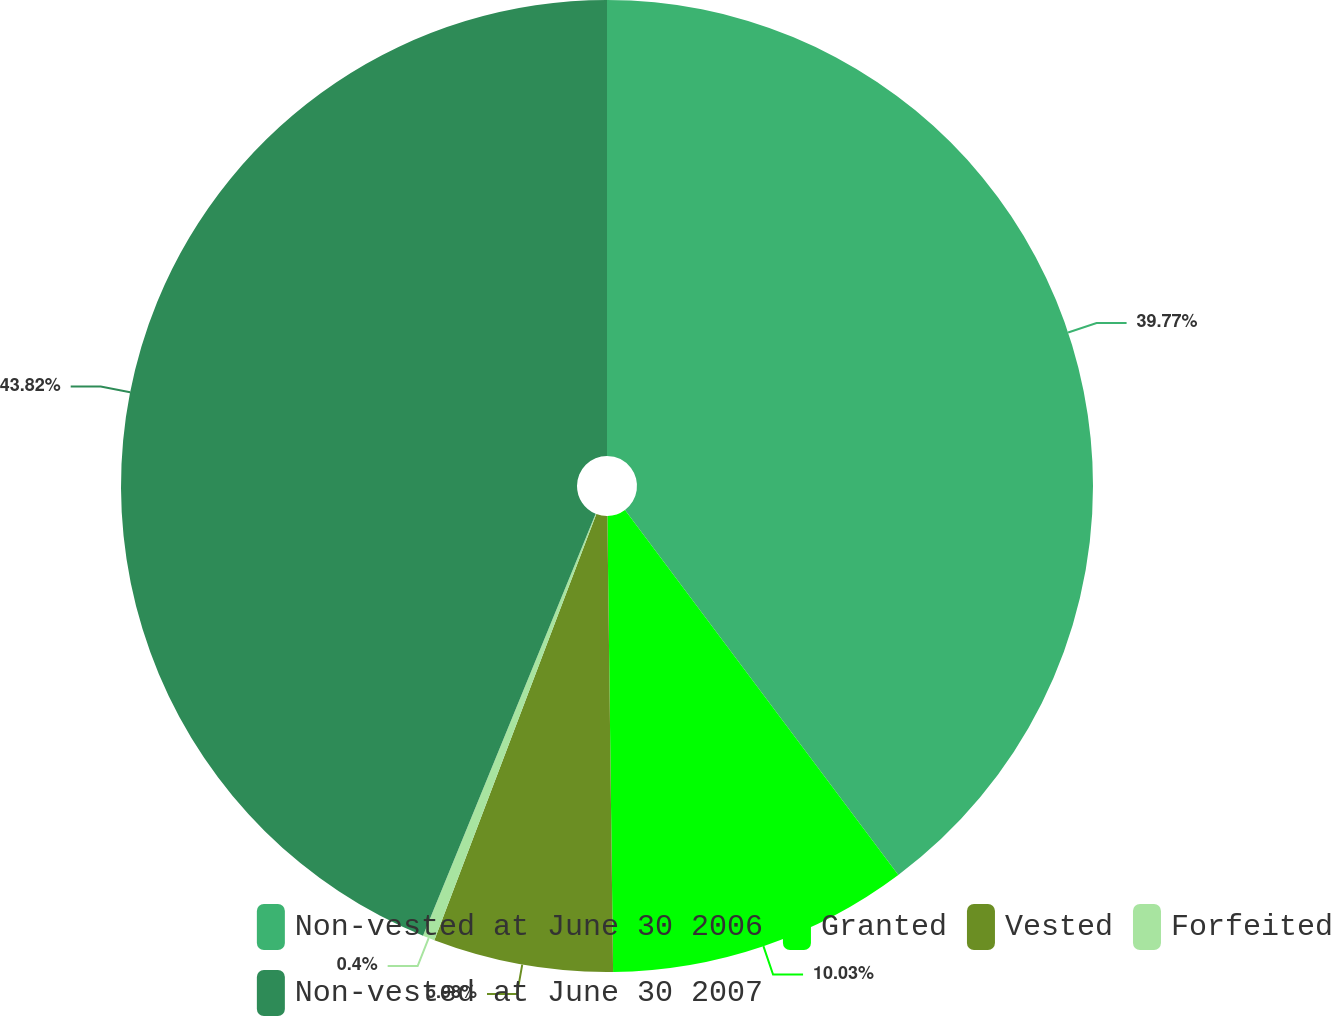Convert chart. <chart><loc_0><loc_0><loc_500><loc_500><pie_chart><fcel>Non-vested at June 30 2006<fcel>Granted<fcel>Vested<fcel>Forfeited<fcel>Non-vested at June 30 2007<nl><fcel>39.77%<fcel>10.03%<fcel>5.98%<fcel>0.4%<fcel>43.82%<nl></chart> 